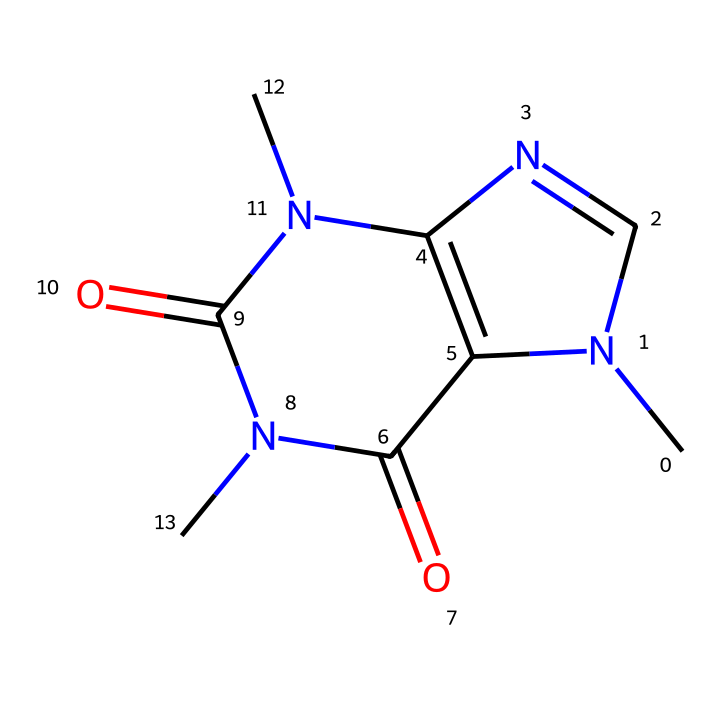how many nitrogen atoms are present in caffeine? The structural representation of caffeine includes three distinct nitrogen atoms identifiable in the rings and side chains of the molecule.
Answer: three what is the molecular formula of caffeine? By analyzing the structure and counting the atoms, caffeine contains 8 carbon, 10 hydrogen, 4 nitrogen, and 2 oxygen atoms, leading to the molecular formula C8H10N4O2.
Answer: C8H10N4O2 what is the role of nitrogen in the structure of caffeine? The nitrogen atoms in caffeine contribute to the molecule's stability and functionality, particularly by participating in hydrogen bonding and affecting the basicity, which influences how caffeine interacts biologically.
Answer: stability and functionality how many rings does the molecular structure of caffeine contain? The SMILES and the drawn structure indicate that caffeine consists of two interconnected ring structures, specifically a pyrimidinedione and a imidazole ring.
Answer: two what type of compound is caffeine classified as? Caffeine is classified as an alkaloid due to its nitrogenous structure and the physiological effects it produces, commonly found in plants.
Answer: alkaloid what property of caffeine is influenced by its molecular structure? The presence of nitrogen atoms and the overall arrangement of carbon and oxygen contribute to caffeine's solubility in water, allowing it to dissolve in coffee easily.
Answer: solubility in water what is a potential biological effect of caffeine due to its structure? The specific arrangement of nitrogen and carbon atoms enables caffeine to block adenosine receptors in the brain, leading to increased alertness and reduced fatigue.
Answer: increased alertness 